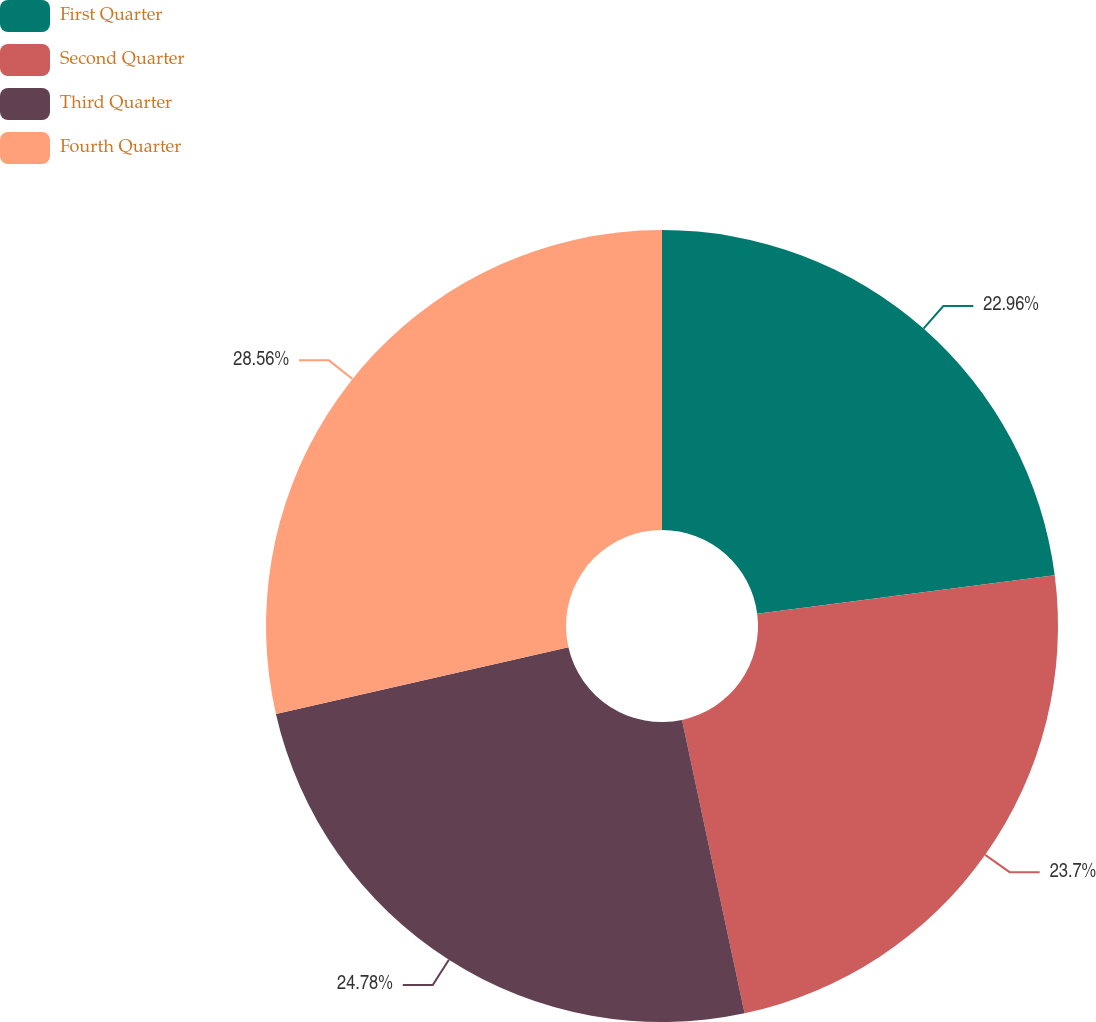<chart> <loc_0><loc_0><loc_500><loc_500><pie_chart><fcel>First Quarter<fcel>Second Quarter<fcel>Third Quarter<fcel>Fourth Quarter<nl><fcel>22.96%<fcel>23.7%<fcel>24.78%<fcel>28.57%<nl></chart> 